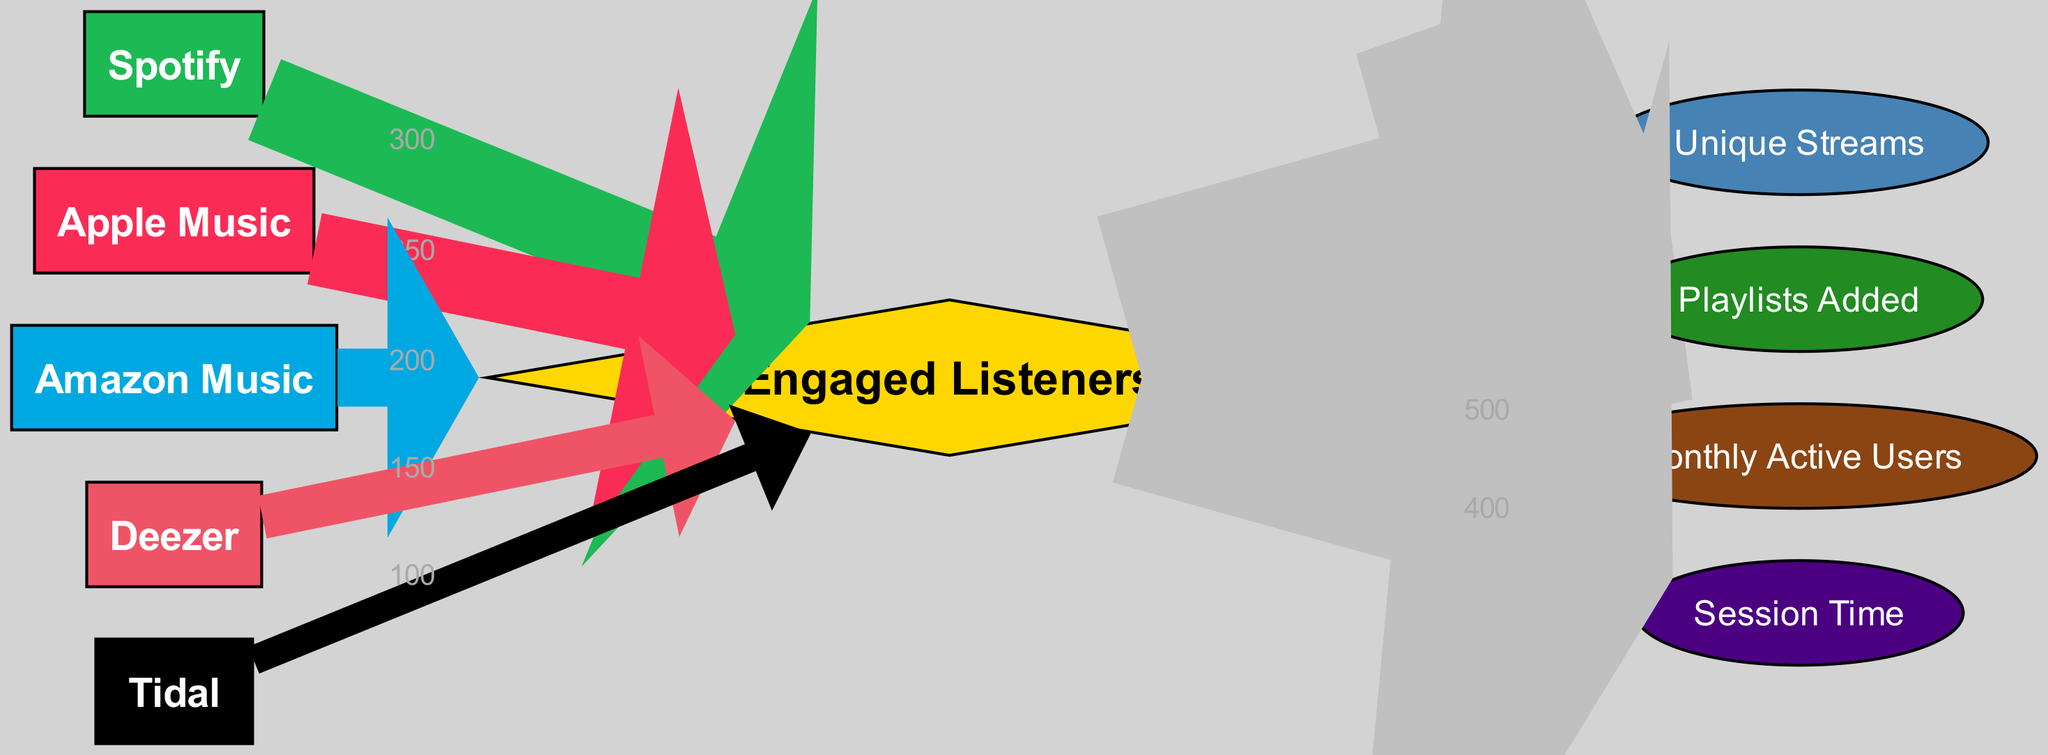What is the value of engaged listeners from Spotify? The diagram shows a direct flow from Spotify to Engaged Listeners with a value of 300. By locating the link from Spotify to Engaged Listeners, we see the value indicated.
Answer: 300 Which service has the highest number of engaged listeners? By comparing the values flowing into the Engaged Listeners node from each service, Spotify has 300, Apple Music has 250, Amazon Music has 200, Deezer has 150, and Tidal has 100. The highest value is from Spotify.
Answer: Spotify What is the total number of unique streams from engaged listeners? The flow of Unique Streams from Engaged Listeners is 800. This is derived directly from the link connecting these two nodes, indicating the total unique streams that come from the engaged listener metrics.
Answer: 800 How many playlists were added based on engaged listeners? Referring to the connection between Engaged Listeners and Playlists Added, the value shown is 600. This indicates the number of playlists added due to engaged listeners.
Answer: 600 What is the relationship between Apple Music and session time? Apple Music has a flow to Engaged Listeners with a value of 250, while Session Time derives from Engaged Listeners with a value of 400. There is no direct link from Apple Music to Session Time, so the relationship is indirect through Engaged Listeners.
Answer: Indirect Which music service has the lowest engagement? Examining the values connecting each music service to Engaged Listeners, Tidal has the lowest value of 100, indicating the least engagement in this quarter.
Answer: Tidal How many connections lead to the engaged listeners node? The Engaged Listeners node receives direct flows from five music services: Spotify, Apple Music, Amazon Music, Deezer, and Tidal, resulting in a total of five connections.
Answer: 5 What is the sum of all engaged listeners across the music services? The engaged listeners are 300 (Spotify) + 250 (Apple Music) + 200 (Amazon Music) + 150 (Deezer) + 100 (Tidal), which totals to 1000. To find the sum, all values contributing to Engaged Listeners are added together.
Answer: 1000 How is the flow from engaged listeners to session time represented? The diagram shows a direct connection from Engaged Listeners to Session Time with a value of 400, which indicates how session time is influenced by the number of engaged listeners.
Answer: 400 